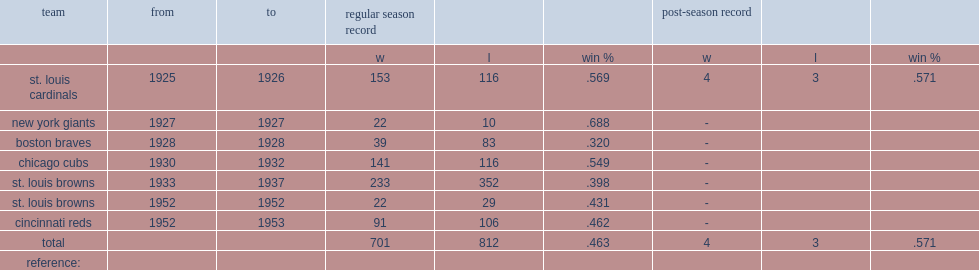When did rogers hornsby play for st. louis browns? 1933.0. Can you parse all the data within this table? {'header': ['team', 'from', 'to', 'regular season record', '', '', 'post-season record', '', ''], 'rows': [['', '', '', 'w', 'l', 'win %', 'w', 'l', 'win %'], ['st. louis cardinals', '1925', '1926', '153', '116', '.569', '4', '3', '.571'], ['new york giants', '1927', '1927', '22', '10', '.688', '-', '', ''], ['boston braves', '1928', '1928', '39', '83', '.320', '-', '', ''], ['chicago cubs', '1930', '1932', '141', '116', '.549', '-', '', ''], ['st. louis browns', '1933', '1937', '233', '352', '.398', '-', '', ''], ['st. louis browns', '1952', '1952', '22', '29', '.431', '-', '', ''], ['cincinnati reds', '1952', '1953', '91', '106', '.462', '-', '', ''], ['total', '', '', '701', '812', '.463', '4', '3', '.571'], ['reference:', '', '', '', '', '', '', '', '']]} 